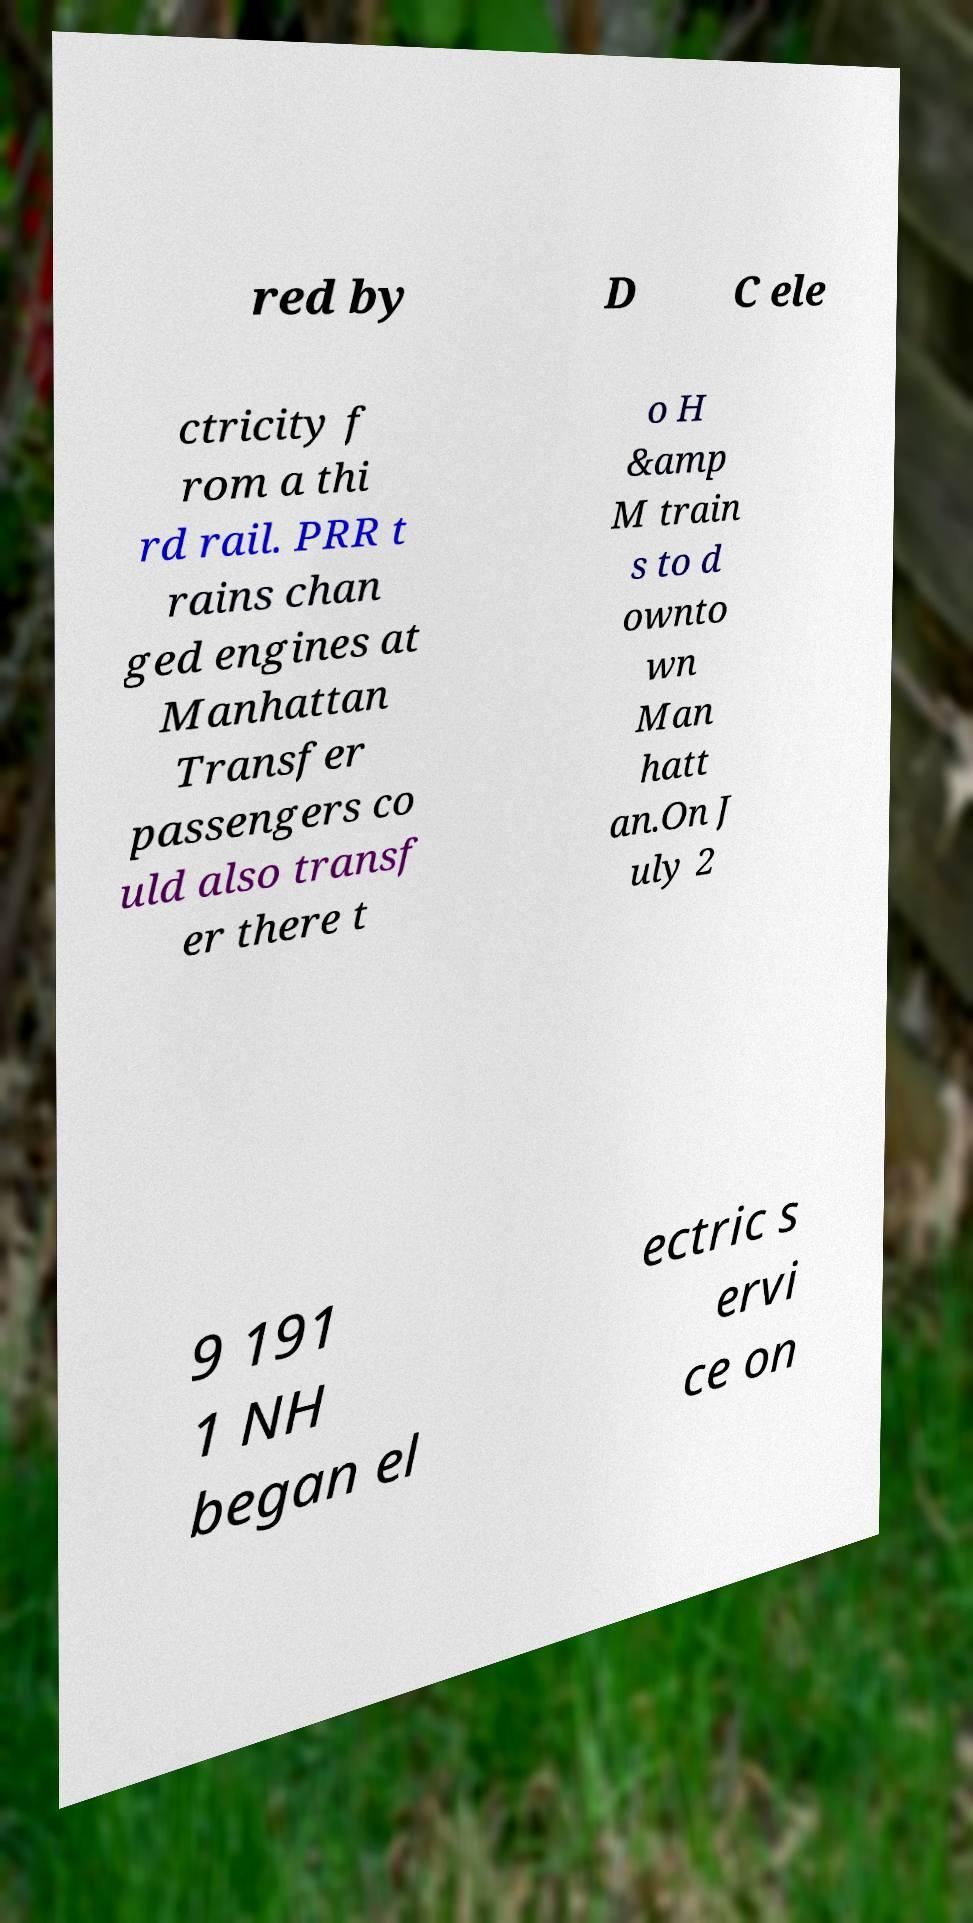Can you read and provide the text displayed in the image?This photo seems to have some interesting text. Can you extract and type it out for me? red by D C ele ctricity f rom a thi rd rail. PRR t rains chan ged engines at Manhattan Transfer passengers co uld also transf er there t o H &amp M train s to d ownto wn Man hatt an.On J uly 2 9 191 1 NH began el ectric s ervi ce on 